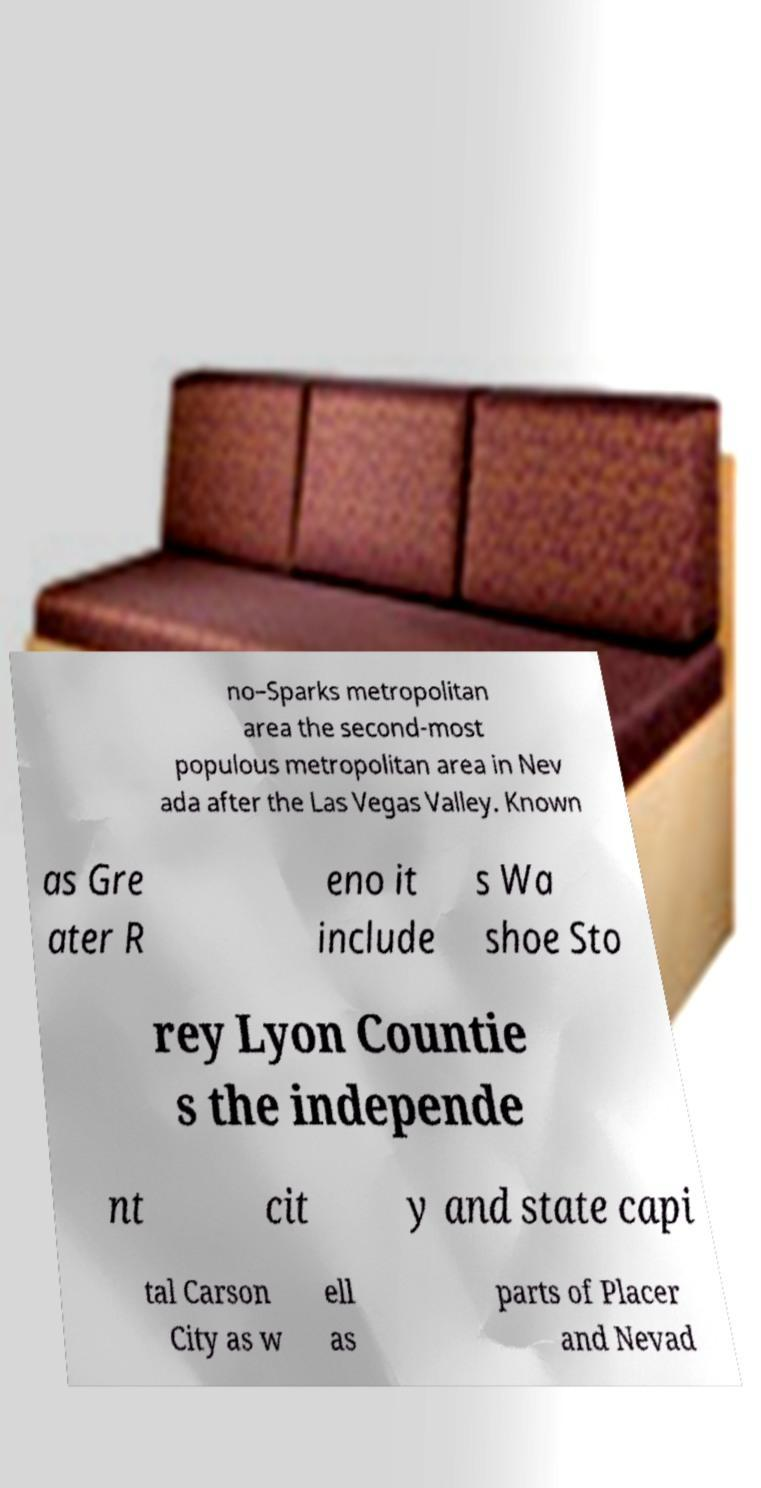What messages or text are displayed in this image? I need them in a readable, typed format. no–Sparks metropolitan area the second-most populous metropolitan area in Nev ada after the Las Vegas Valley. Known as Gre ater R eno it include s Wa shoe Sto rey Lyon Countie s the independe nt cit y and state capi tal Carson City as w ell as parts of Placer and Nevad 